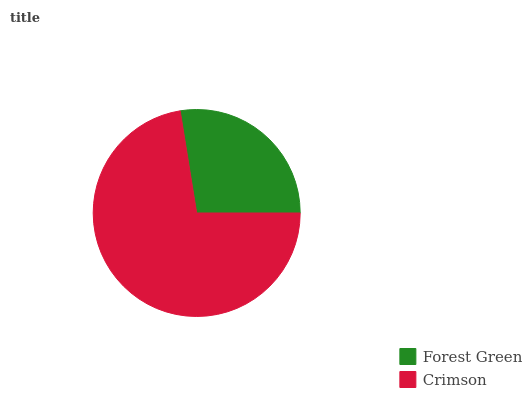Is Forest Green the minimum?
Answer yes or no. Yes. Is Crimson the maximum?
Answer yes or no. Yes. Is Crimson the minimum?
Answer yes or no. No. Is Crimson greater than Forest Green?
Answer yes or no. Yes. Is Forest Green less than Crimson?
Answer yes or no. Yes. Is Forest Green greater than Crimson?
Answer yes or no. No. Is Crimson less than Forest Green?
Answer yes or no. No. Is Crimson the high median?
Answer yes or no. Yes. Is Forest Green the low median?
Answer yes or no. Yes. Is Forest Green the high median?
Answer yes or no. No. Is Crimson the low median?
Answer yes or no. No. 